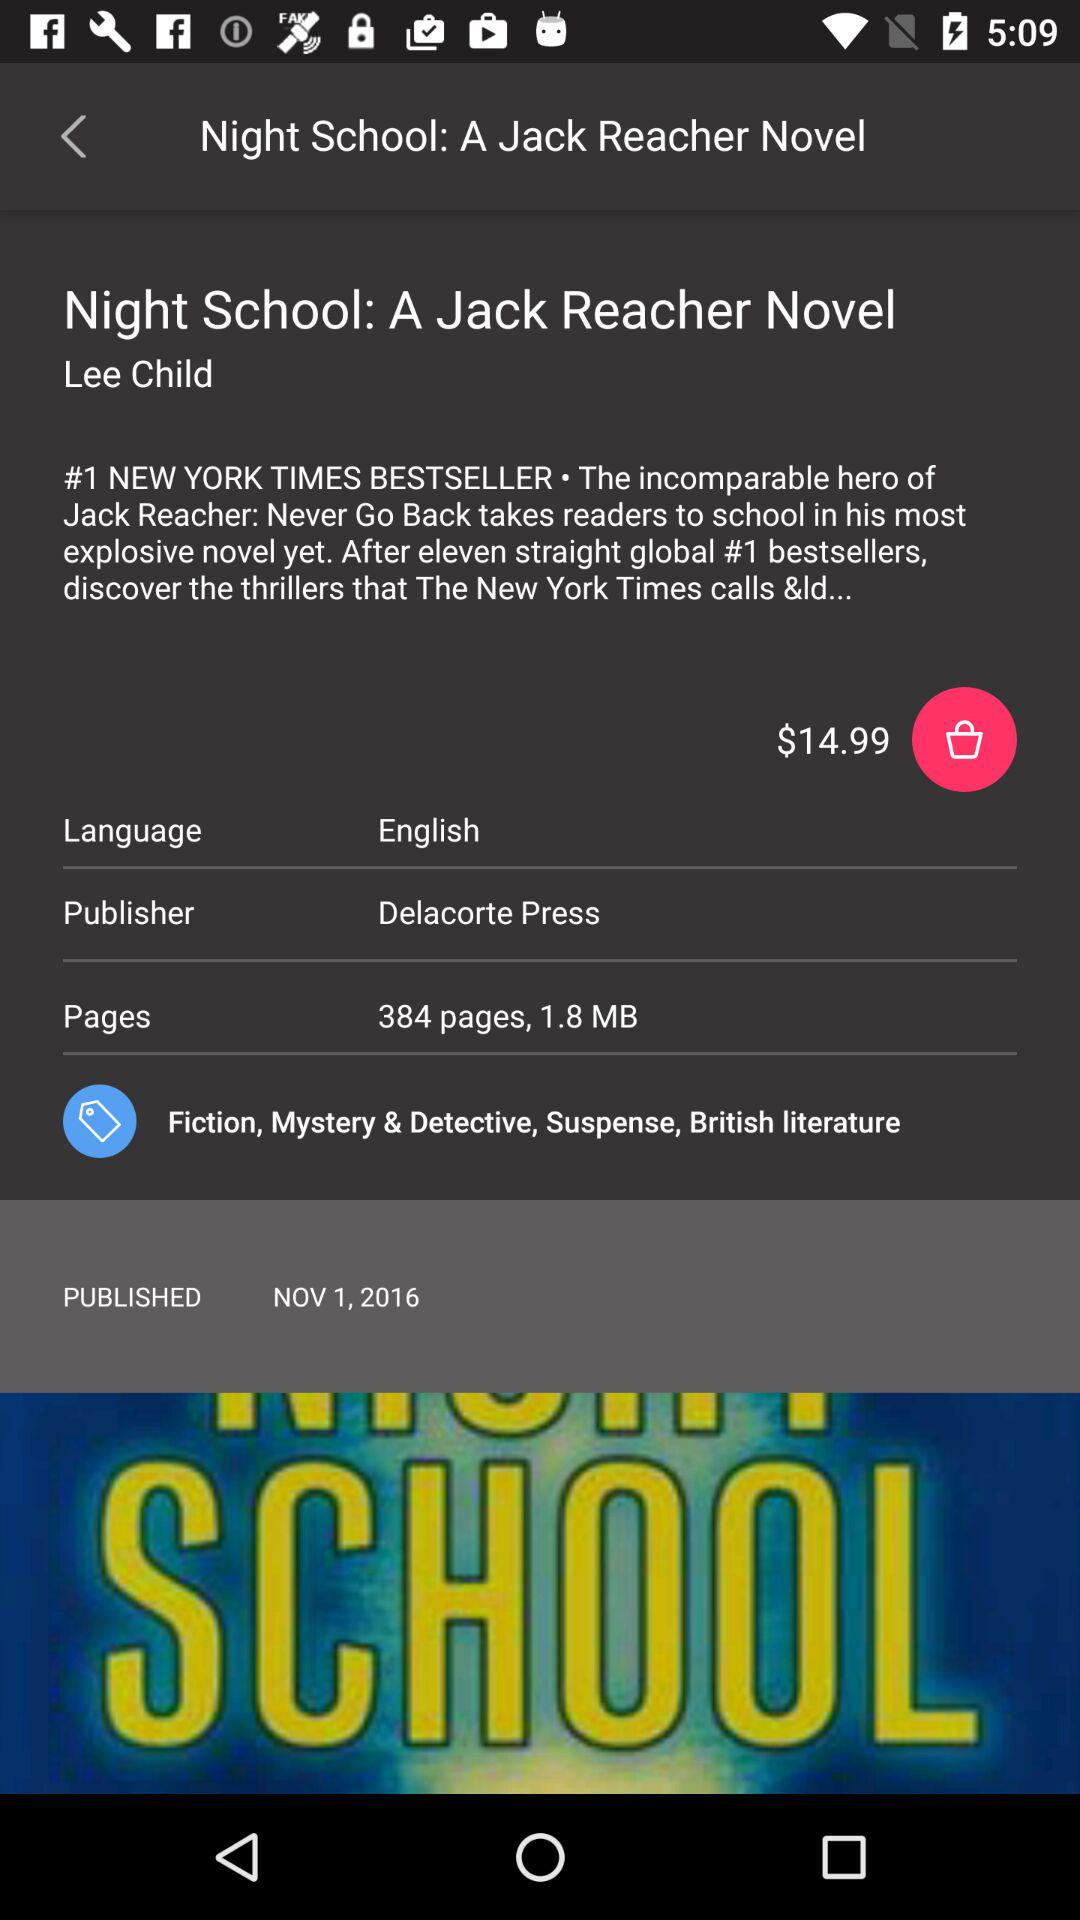How much does it cost for one copy of the novel? One copy of the novel costs $14.99. 